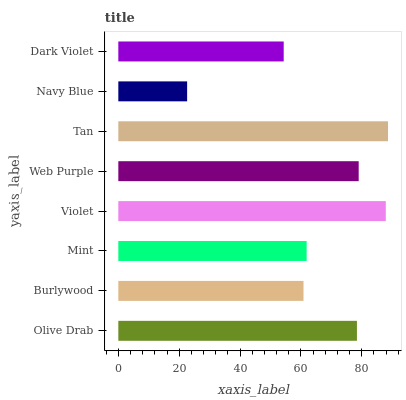Is Navy Blue the minimum?
Answer yes or no. Yes. Is Tan the maximum?
Answer yes or no. Yes. Is Burlywood the minimum?
Answer yes or no. No. Is Burlywood the maximum?
Answer yes or no. No. Is Olive Drab greater than Burlywood?
Answer yes or no. Yes. Is Burlywood less than Olive Drab?
Answer yes or no. Yes. Is Burlywood greater than Olive Drab?
Answer yes or no. No. Is Olive Drab less than Burlywood?
Answer yes or no. No. Is Olive Drab the high median?
Answer yes or no. Yes. Is Mint the low median?
Answer yes or no. Yes. Is Burlywood the high median?
Answer yes or no. No. Is Navy Blue the low median?
Answer yes or no. No. 